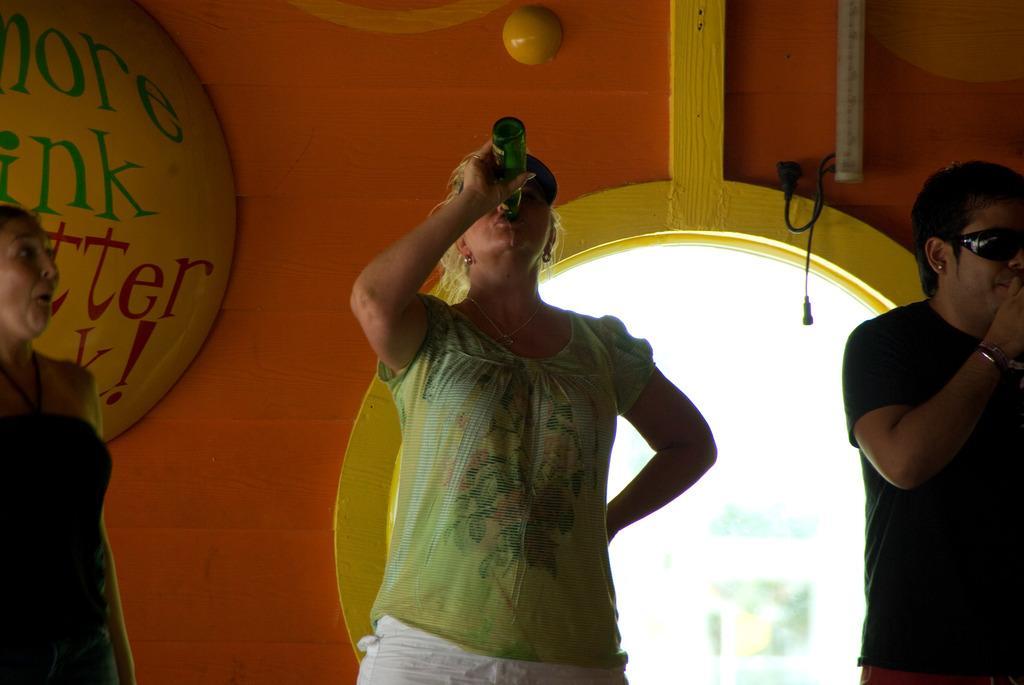How would you summarize this image in a sentence or two? In this picture we can see three people and one woman is holding a bottle and in the background we can see a wall and some objects. 